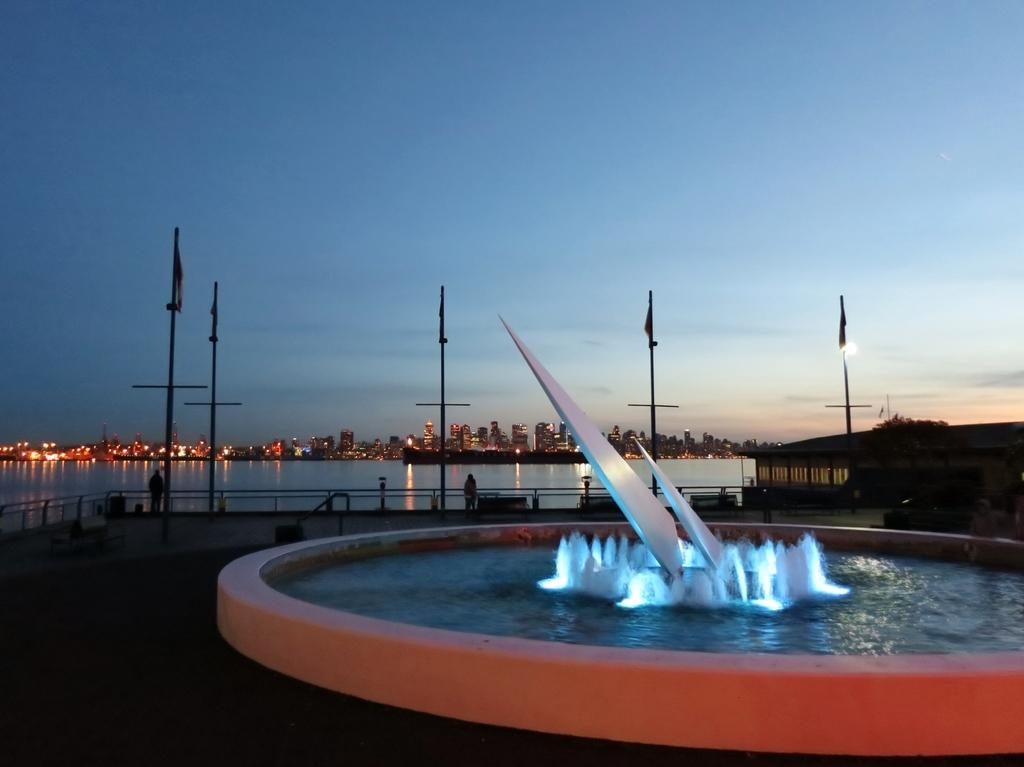What is visible in the image? Water is visible in the image. What can be seen in the background of the image? There are buildings and clouds in the sky in the background of the image. What feature do the buildings in the image have? The buildings have lights. Where is the baseball located in the image? There is no baseball present in the image. What is the middle of the image showing? The image does not have a specific "middle" as it is a photograph, not a map or diagram. --- 